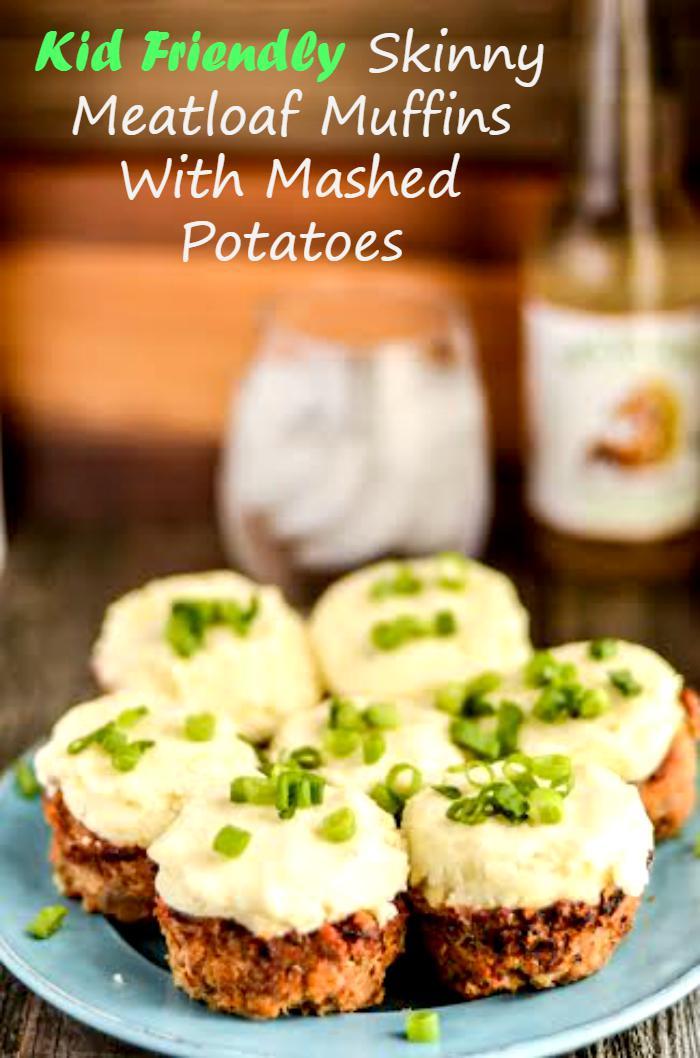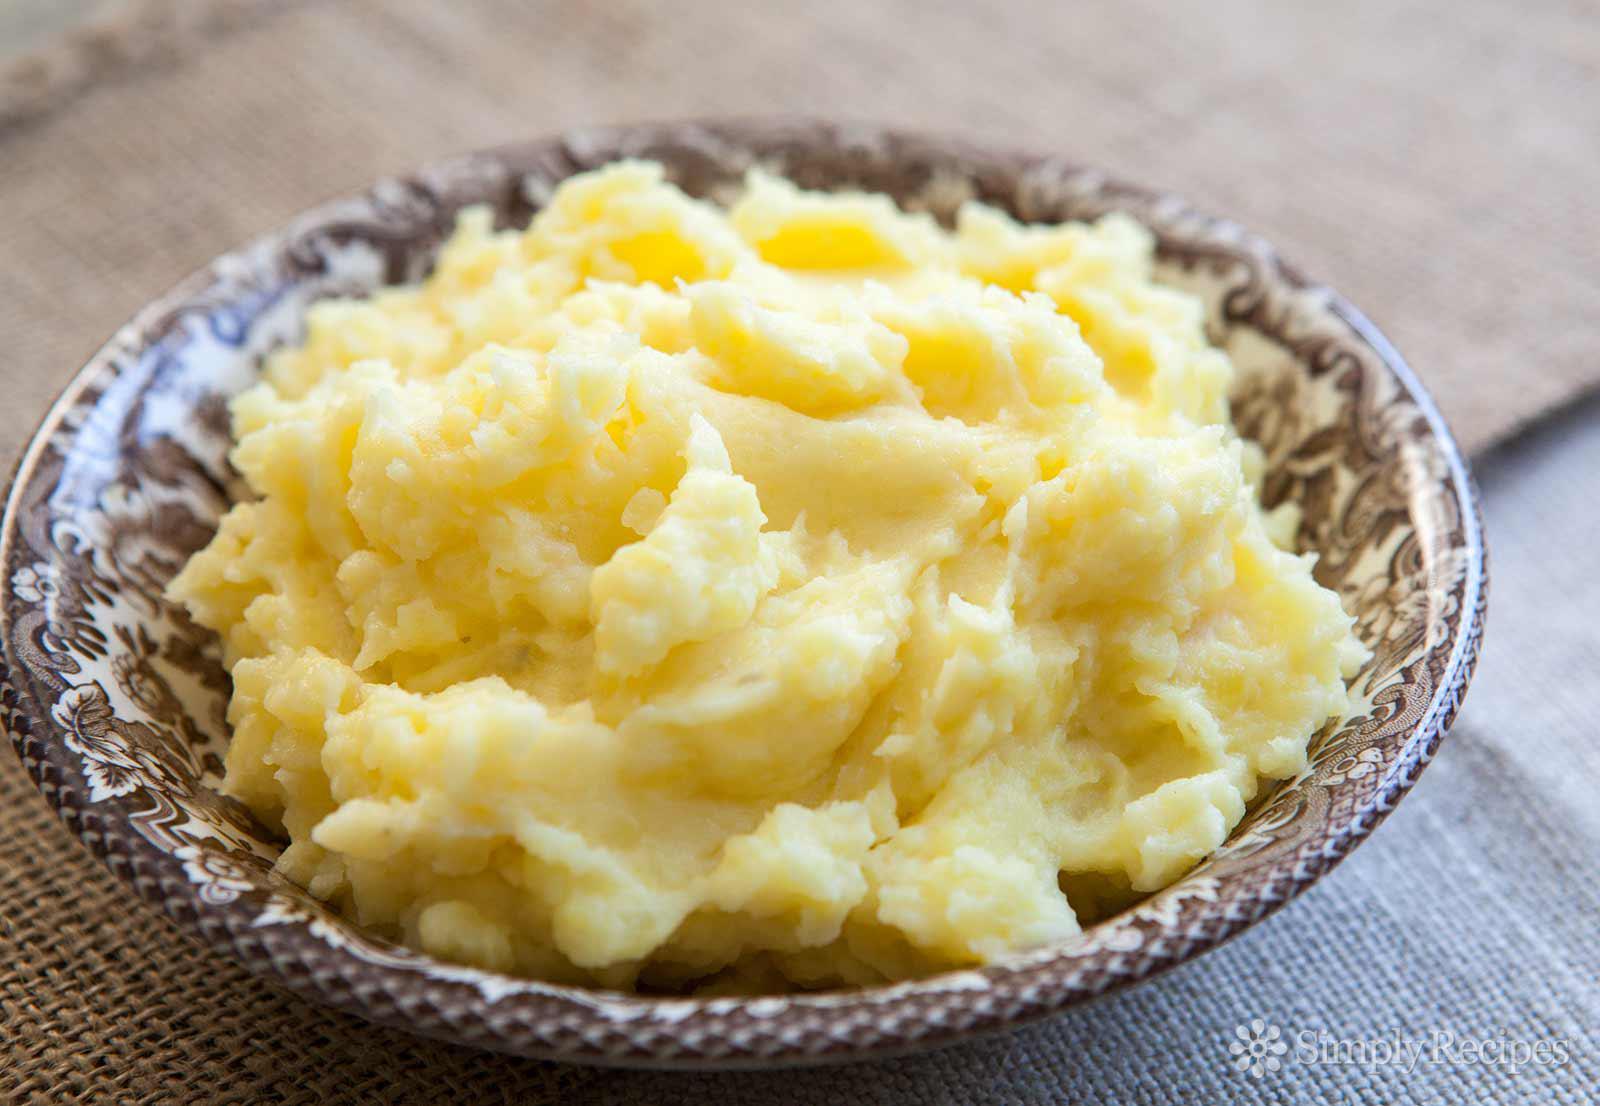The first image is the image on the left, the second image is the image on the right. Evaluate the accuracy of this statement regarding the images: "At least one image in the set features a green garnish on top of the food and other dishes in the background.". Is it true? Answer yes or no. Yes. The first image is the image on the left, the second image is the image on the right. Examine the images to the left and right. Is the description "A silverware serving utensil is in one image with a bowl of mashed potatoes." accurate? Answer yes or no. No. 